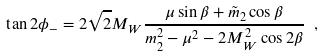<formula> <loc_0><loc_0><loc_500><loc_500>\tan 2 \phi _ { - } = 2 \sqrt { 2 } M _ { W } \frac { \mu \sin \beta + \tilde { m } _ { 2 } \cos \beta } { m ^ { 2 } _ { 2 } - \mu ^ { 2 } - 2 M _ { W } ^ { 2 } \cos 2 \beta } \ ,</formula> 